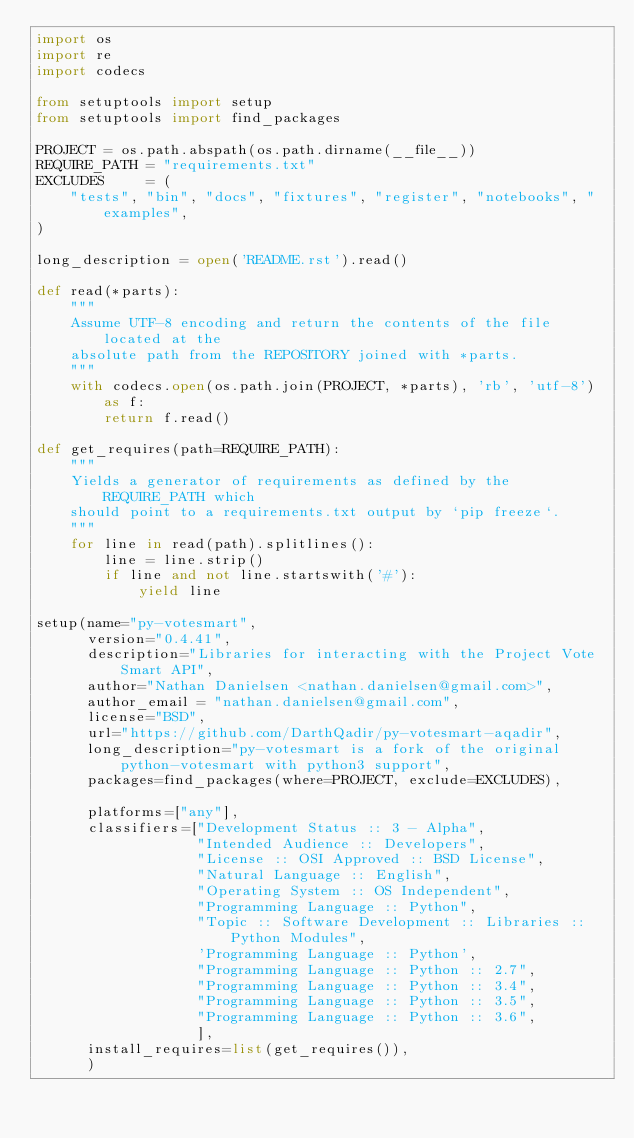<code> <loc_0><loc_0><loc_500><loc_500><_Python_>import os
import re
import codecs

from setuptools import setup
from setuptools import find_packages

PROJECT = os.path.abspath(os.path.dirname(__file__))
REQUIRE_PATH = "requirements.txt"
EXCLUDES     = (
    "tests", "bin", "docs", "fixtures", "register", "notebooks", "examples",
)

long_description = open('README.rst').read()

def read(*parts):
    """
    Assume UTF-8 encoding and return the contents of the file located at the
    absolute path from the REPOSITORY joined with *parts.
    """
    with codecs.open(os.path.join(PROJECT, *parts), 'rb', 'utf-8') as f:
        return f.read()

def get_requires(path=REQUIRE_PATH):
    """
    Yields a generator of requirements as defined by the REQUIRE_PATH which
    should point to a requirements.txt output by `pip freeze`.
    """
    for line in read(path).splitlines():
        line = line.strip()
        if line and not line.startswith('#'):
            yield line

setup(name="py-votesmart",
      version="0.4.41",
      description="Libraries for interacting with the Project Vote Smart API",
      author="Nathan Danielsen <nathan.danielsen@gmail.com>",
      author_email = "nathan.danielsen@gmail.com",
      license="BSD",
      url="https://github.com/DarthQadir/py-votesmart-aqadir",
      long_description="py-votesmart is a fork of the original python-votesmart with python3 support",
      packages=find_packages(where=PROJECT, exclude=EXCLUDES),

      platforms=["any"],
      classifiers=["Development Status :: 3 - Alpha",
                   "Intended Audience :: Developers",
                   "License :: OSI Approved :: BSD License",
                   "Natural Language :: English",
                   "Operating System :: OS Independent",
                   "Programming Language :: Python",
                   "Topic :: Software Development :: Libraries :: Python Modules",
                   'Programming Language :: Python',
                   "Programming Language :: Python :: 2.7",
                   "Programming Language :: Python :: 3.4",
                   "Programming Language :: Python :: 3.5",
                   "Programming Language :: Python :: 3.6",
                   ],
      install_requires=list(get_requires()),
      )
</code> 